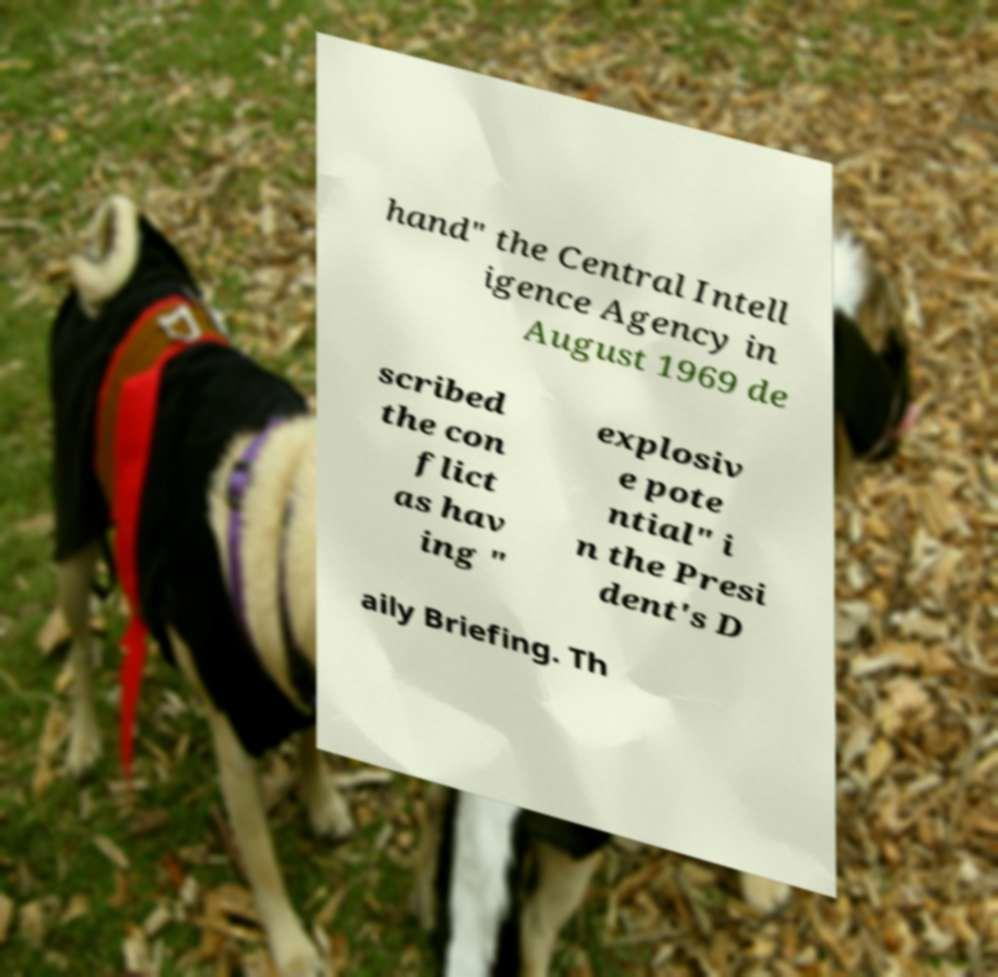Can you read and provide the text displayed in the image?This photo seems to have some interesting text. Can you extract and type it out for me? hand" the Central Intell igence Agency in August 1969 de scribed the con flict as hav ing " explosiv e pote ntial" i n the Presi dent's D aily Briefing. Th 